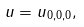<formula> <loc_0><loc_0><loc_500><loc_500>\| u \| = \| u \| _ { 0 , 0 , 0 } ,</formula> 